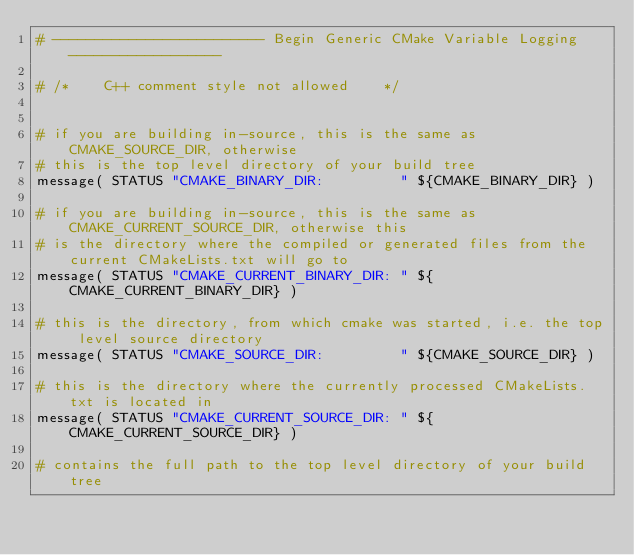Convert code to text. <code><loc_0><loc_0><loc_500><loc_500><_CMake_># ------------------------- Begin Generic CMake Variable Logging ------------------

# /*    C++ comment style not allowed    */


# if you are building in-source, this is the same as CMAKE_SOURCE_DIR, otherwise 
# this is the top level directory of your build tree 
message( STATUS "CMAKE_BINARY_DIR:         " ${CMAKE_BINARY_DIR} )

# if you are building in-source, this is the same as CMAKE_CURRENT_SOURCE_DIR, otherwise this 
# is the directory where the compiled or generated files from the current CMakeLists.txt will go to 
message( STATUS "CMAKE_CURRENT_BINARY_DIR: " ${CMAKE_CURRENT_BINARY_DIR} )

# this is the directory, from which cmake was started, i.e. the top level source directory 
message( STATUS "CMAKE_SOURCE_DIR:         " ${CMAKE_SOURCE_DIR} )

# this is the directory where the currently processed CMakeLists.txt is located in 
message( STATUS "CMAKE_CURRENT_SOURCE_DIR: " ${CMAKE_CURRENT_SOURCE_DIR} )

# contains the full path to the top level directory of your build tree </code> 